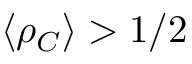<formula> <loc_0><loc_0><loc_500><loc_500>\langle \rho _ { C } \rangle > 1 / 2</formula> 